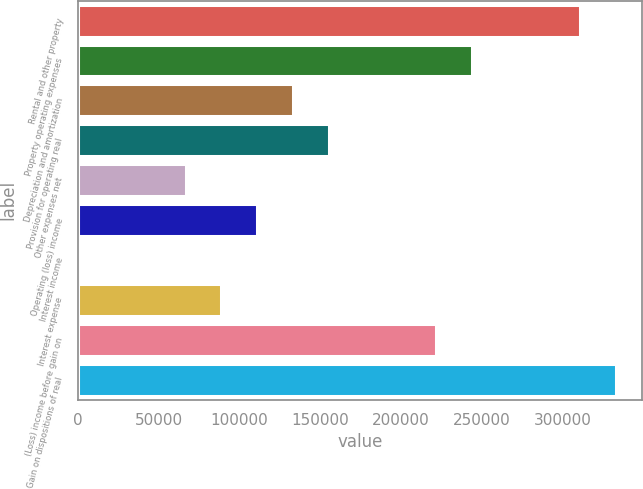<chart> <loc_0><loc_0><loc_500><loc_500><bar_chart><fcel>Rental and other property<fcel>Property operating expenses<fcel>Depreciation and amortization<fcel>Provision for operating real<fcel>Other expenses net<fcel>Operating (loss) income<fcel>Interest income<fcel>Interest expense<fcel>(Loss) income before gain on<fcel>Gain on dispositions of real<nl><fcel>310465<fcel>243961<fcel>133121<fcel>155289<fcel>66616.3<fcel>110952<fcel>112<fcel>88784.4<fcel>221793<fcel>332634<nl></chart> 